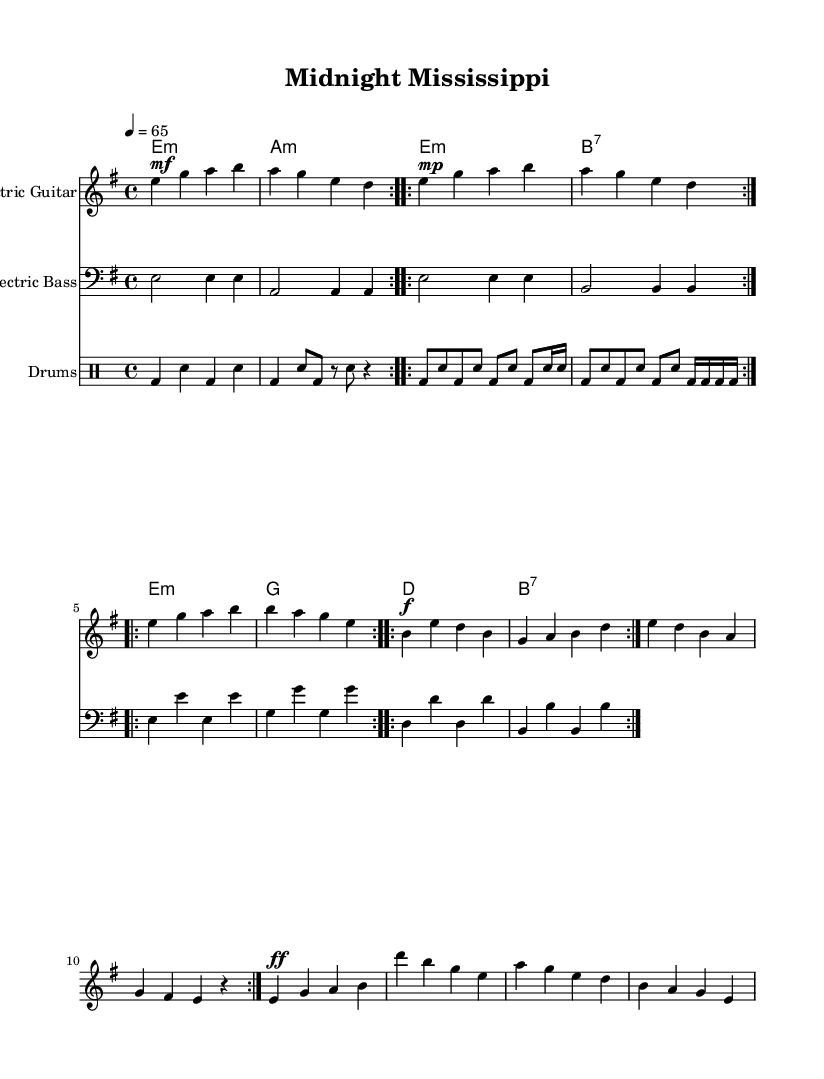What is the key signature of this music? The key signature indicates the presence of one sharp, which signifies that the key is E minor.
Answer: E minor What is the time signature of this music? The time signature shown at the beginning of the piece is '4/4', which means there are four beats in each measure.
Answer: 4/4 What is the tempo marking for the piece? The tempo marking indicates a speed of 65 beats per minute, as shown in the tempo indication at the beginning of the score.
Answer: 65 How many measures are in the verse section? The verse section is repeated twice, and consists of four measures in each repeat, totaling eight measures.
Answer: 8 What instrument plays the deepest bass line in this piece? The electric bass part is specifically indicated as playing the lowest notes, providing the deep resonant bass lines characteristic of the style.
Answer: Electric Bass What chords are used in the chorus? The chorus consists of four chords: E minor, G major, D major, and B7, which are noted in the chord section under the staff.
Answer: E minor, G, D, B7 What music style does this piece represent? The combination of slide guitar techniques, deep bass lines, and the overall structure reflects the genre of Delta-inspired electric blues.
Answer: Delta-inspired electric blues 